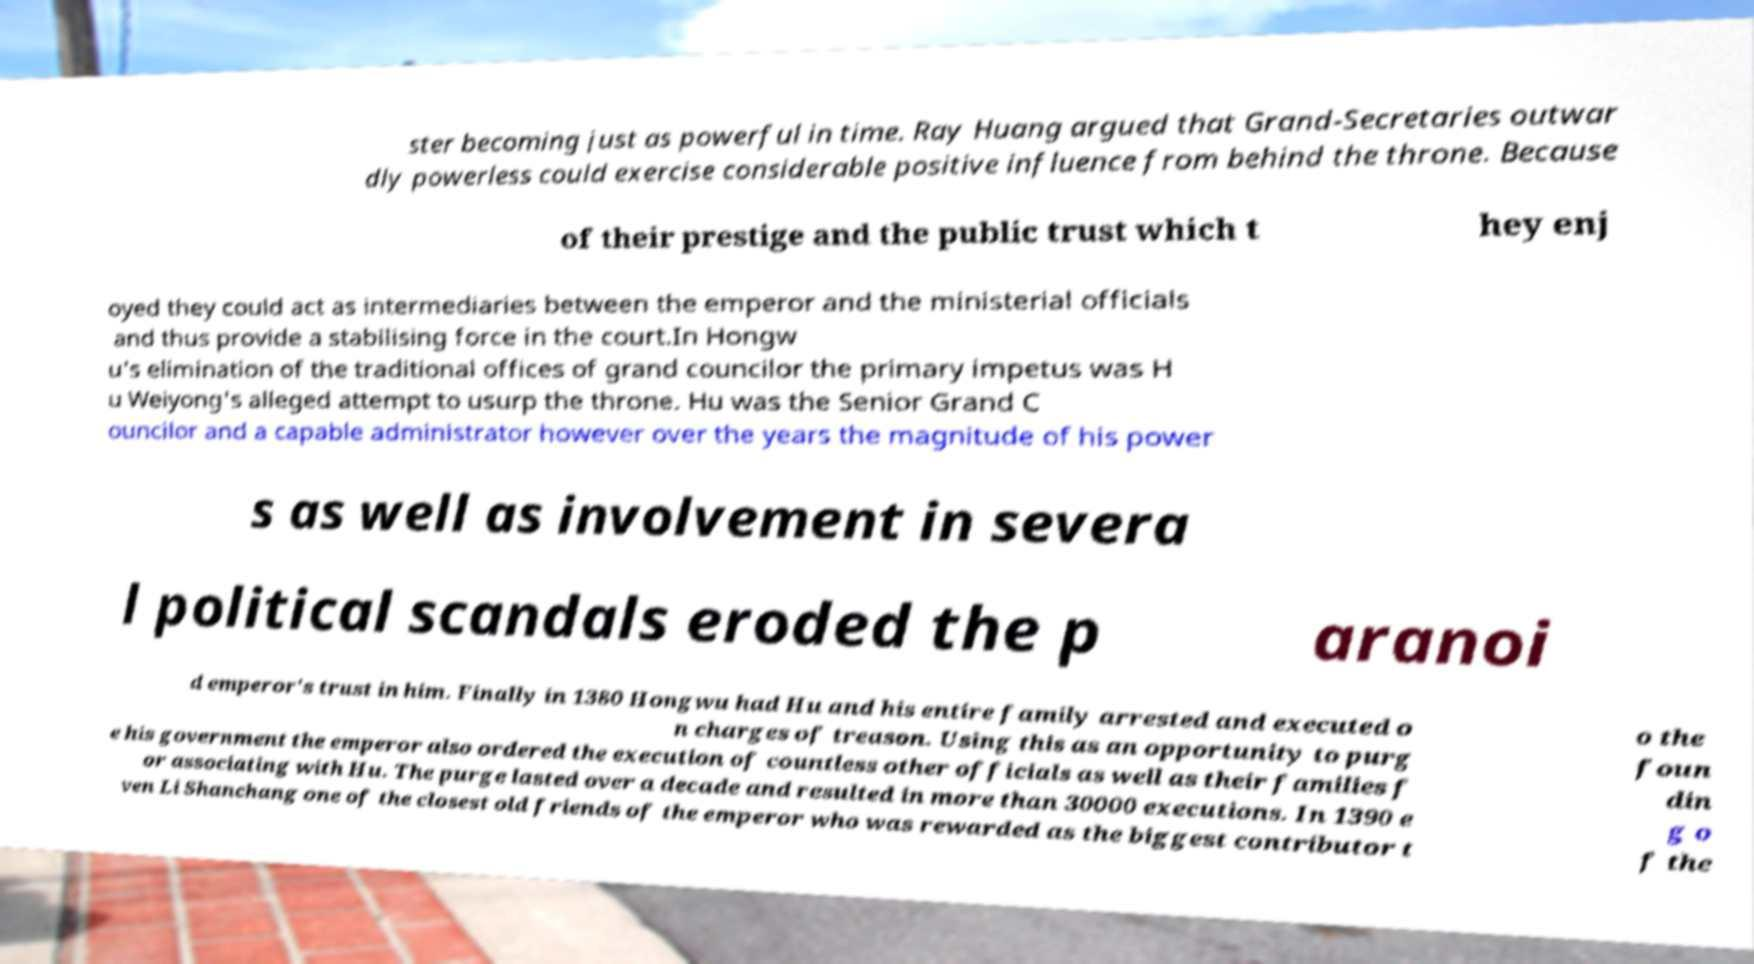There's text embedded in this image that I need extracted. Can you transcribe it verbatim? ster becoming just as powerful in time. Ray Huang argued that Grand-Secretaries outwar dly powerless could exercise considerable positive influence from behind the throne. Because of their prestige and the public trust which t hey enj oyed they could act as intermediaries between the emperor and the ministerial officials and thus provide a stabilising force in the court.In Hongw u's elimination of the traditional offices of grand councilor the primary impetus was H u Weiyong's alleged attempt to usurp the throne. Hu was the Senior Grand C ouncilor and a capable administrator however over the years the magnitude of his power s as well as involvement in severa l political scandals eroded the p aranoi d emperor's trust in him. Finally in 1380 Hongwu had Hu and his entire family arrested and executed o n charges of treason. Using this as an opportunity to purg e his government the emperor also ordered the execution of countless other officials as well as their families f or associating with Hu. The purge lasted over a decade and resulted in more than 30000 executions. In 1390 e ven Li Shanchang one of the closest old friends of the emperor who was rewarded as the biggest contributor t o the foun din g o f the 